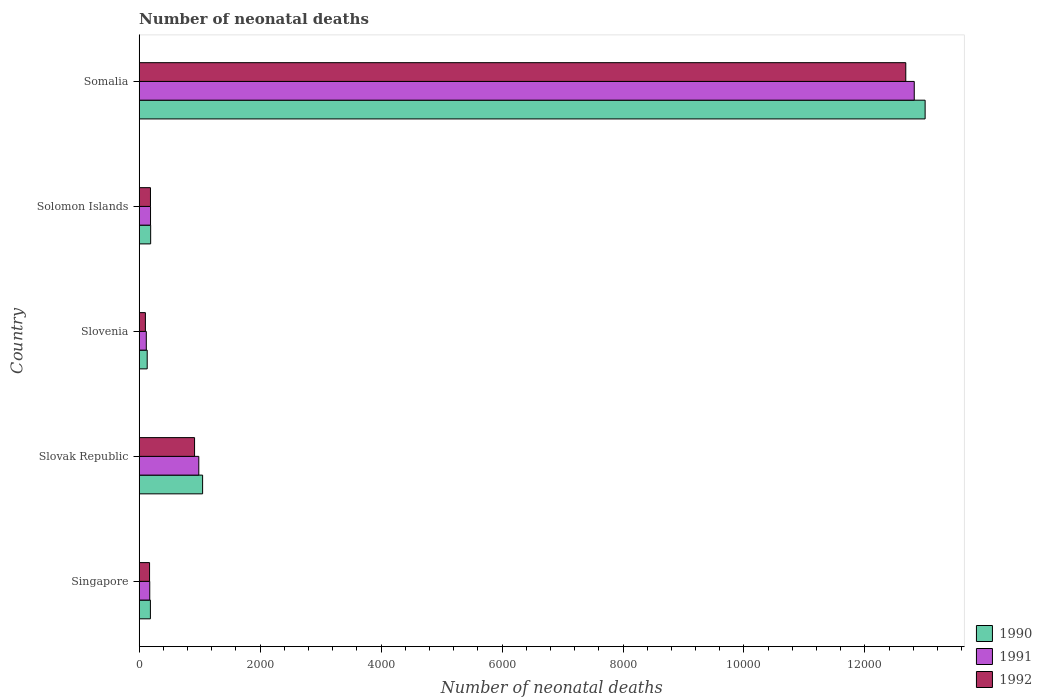How many different coloured bars are there?
Make the answer very short. 3. How many bars are there on the 5th tick from the top?
Your response must be concise. 3. What is the label of the 1st group of bars from the top?
Offer a terse response. Somalia. In how many cases, is the number of bars for a given country not equal to the number of legend labels?
Make the answer very short. 0. What is the number of neonatal deaths in in 1992 in Slovak Republic?
Provide a short and direct response. 916. Across all countries, what is the maximum number of neonatal deaths in in 1991?
Your answer should be compact. 1.28e+04. Across all countries, what is the minimum number of neonatal deaths in in 1991?
Offer a terse response. 118. In which country was the number of neonatal deaths in in 1990 maximum?
Your answer should be compact. Somalia. In which country was the number of neonatal deaths in in 1992 minimum?
Give a very brief answer. Slovenia. What is the total number of neonatal deaths in in 1992 in the graph?
Make the answer very short. 1.41e+04. What is the difference between the number of neonatal deaths in in 1990 in Singapore and that in Solomon Islands?
Give a very brief answer. -4. What is the difference between the number of neonatal deaths in in 1992 in Slovak Republic and the number of neonatal deaths in in 1991 in Solomon Islands?
Ensure brevity in your answer.  728. What is the average number of neonatal deaths in in 1991 per country?
Ensure brevity in your answer.  2856.4. What is the difference between the number of neonatal deaths in in 1990 and number of neonatal deaths in in 1992 in Slovenia?
Provide a succinct answer. 30. In how many countries, is the number of neonatal deaths in in 1992 greater than 10400 ?
Ensure brevity in your answer.  1. What is the ratio of the number of neonatal deaths in in 1992 in Singapore to that in Slovenia?
Ensure brevity in your answer.  1.67. What is the difference between the highest and the second highest number of neonatal deaths in in 1992?
Your answer should be very brief. 1.18e+04. What is the difference between the highest and the lowest number of neonatal deaths in in 1991?
Ensure brevity in your answer.  1.27e+04. In how many countries, is the number of neonatal deaths in in 1992 greater than the average number of neonatal deaths in in 1992 taken over all countries?
Your response must be concise. 1. What does the 3rd bar from the bottom in Slovenia represents?
Your response must be concise. 1992. Is it the case that in every country, the sum of the number of neonatal deaths in in 1991 and number of neonatal deaths in in 1990 is greater than the number of neonatal deaths in in 1992?
Offer a terse response. Yes. How many bars are there?
Your response must be concise. 15. Are all the bars in the graph horizontal?
Offer a very short reply. Yes. How many countries are there in the graph?
Offer a terse response. 5. What is the difference between two consecutive major ticks on the X-axis?
Your response must be concise. 2000. Are the values on the major ticks of X-axis written in scientific E-notation?
Offer a very short reply. No. How are the legend labels stacked?
Ensure brevity in your answer.  Vertical. What is the title of the graph?
Offer a very short reply. Number of neonatal deaths. What is the label or title of the X-axis?
Offer a very short reply. Number of neonatal deaths. What is the Number of neonatal deaths of 1990 in Singapore?
Your answer should be compact. 186. What is the Number of neonatal deaths in 1991 in Singapore?
Your response must be concise. 175. What is the Number of neonatal deaths of 1992 in Singapore?
Offer a very short reply. 172. What is the Number of neonatal deaths of 1990 in Slovak Republic?
Ensure brevity in your answer.  1049. What is the Number of neonatal deaths of 1991 in Slovak Republic?
Give a very brief answer. 986. What is the Number of neonatal deaths in 1992 in Slovak Republic?
Ensure brevity in your answer.  916. What is the Number of neonatal deaths of 1990 in Slovenia?
Ensure brevity in your answer.  133. What is the Number of neonatal deaths of 1991 in Slovenia?
Your answer should be very brief. 118. What is the Number of neonatal deaths in 1992 in Slovenia?
Give a very brief answer. 103. What is the Number of neonatal deaths of 1990 in Solomon Islands?
Your response must be concise. 190. What is the Number of neonatal deaths of 1991 in Solomon Islands?
Provide a succinct answer. 188. What is the Number of neonatal deaths of 1992 in Solomon Islands?
Provide a succinct answer. 187. What is the Number of neonatal deaths of 1990 in Somalia?
Offer a terse response. 1.30e+04. What is the Number of neonatal deaths of 1991 in Somalia?
Offer a very short reply. 1.28e+04. What is the Number of neonatal deaths of 1992 in Somalia?
Give a very brief answer. 1.27e+04. Across all countries, what is the maximum Number of neonatal deaths of 1990?
Offer a terse response. 1.30e+04. Across all countries, what is the maximum Number of neonatal deaths of 1991?
Provide a short and direct response. 1.28e+04. Across all countries, what is the maximum Number of neonatal deaths in 1992?
Ensure brevity in your answer.  1.27e+04. Across all countries, what is the minimum Number of neonatal deaths of 1990?
Make the answer very short. 133. Across all countries, what is the minimum Number of neonatal deaths of 1991?
Provide a short and direct response. 118. Across all countries, what is the minimum Number of neonatal deaths in 1992?
Ensure brevity in your answer.  103. What is the total Number of neonatal deaths of 1990 in the graph?
Your answer should be very brief. 1.46e+04. What is the total Number of neonatal deaths in 1991 in the graph?
Provide a short and direct response. 1.43e+04. What is the total Number of neonatal deaths in 1992 in the graph?
Offer a very short reply. 1.41e+04. What is the difference between the Number of neonatal deaths in 1990 in Singapore and that in Slovak Republic?
Provide a short and direct response. -863. What is the difference between the Number of neonatal deaths of 1991 in Singapore and that in Slovak Republic?
Provide a short and direct response. -811. What is the difference between the Number of neonatal deaths in 1992 in Singapore and that in Slovak Republic?
Your response must be concise. -744. What is the difference between the Number of neonatal deaths in 1991 in Singapore and that in Slovenia?
Provide a succinct answer. 57. What is the difference between the Number of neonatal deaths of 1992 in Singapore and that in Solomon Islands?
Ensure brevity in your answer.  -15. What is the difference between the Number of neonatal deaths in 1990 in Singapore and that in Somalia?
Offer a terse response. -1.28e+04. What is the difference between the Number of neonatal deaths of 1991 in Singapore and that in Somalia?
Give a very brief answer. -1.26e+04. What is the difference between the Number of neonatal deaths of 1992 in Singapore and that in Somalia?
Offer a very short reply. -1.25e+04. What is the difference between the Number of neonatal deaths of 1990 in Slovak Republic and that in Slovenia?
Offer a terse response. 916. What is the difference between the Number of neonatal deaths in 1991 in Slovak Republic and that in Slovenia?
Your answer should be compact. 868. What is the difference between the Number of neonatal deaths in 1992 in Slovak Republic and that in Slovenia?
Ensure brevity in your answer.  813. What is the difference between the Number of neonatal deaths in 1990 in Slovak Republic and that in Solomon Islands?
Provide a succinct answer. 859. What is the difference between the Number of neonatal deaths of 1991 in Slovak Republic and that in Solomon Islands?
Keep it short and to the point. 798. What is the difference between the Number of neonatal deaths in 1992 in Slovak Republic and that in Solomon Islands?
Your response must be concise. 729. What is the difference between the Number of neonatal deaths in 1990 in Slovak Republic and that in Somalia?
Offer a terse response. -1.19e+04. What is the difference between the Number of neonatal deaths of 1991 in Slovak Republic and that in Somalia?
Your response must be concise. -1.18e+04. What is the difference between the Number of neonatal deaths of 1992 in Slovak Republic and that in Somalia?
Give a very brief answer. -1.18e+04. What is the difference between the Number of neonatal deaths in 1990 in Slovenia and that in Solomon Islands?
Your response must be concise. -57. What is the difference between the Number of neonatal deaths in 1991 in Slovenia and that in Solomon Islands?
Give a very brief answer. -70. What is the difference between the Number of neonatal deaths in 1992 in Slovenia and that in Solomon Islands?
Your answer should be compact. -84. What is the difference between the Number of neonatal deaths of 1990 in Slovenia and that in Somalia?
Give a very brief answer. -1.29e+04. What is the difference between the Number of neonatal deaths of 1991 in Slovenia and that in Somalia?
Offer a terse response. -1.27e+04. What is the difference between the Number of neonatal deaths in 1992 in Slovenia and that in Somalia?
Your answer should be very brief. -1.26e+04. What is the difference between the Number of neonatal deaths in 1990 in Solomon Islands and that in Somalia?
Keep it short and to the point. -1.28e+04. What is the difference between the Number of neonatal deaths of 1991 in Solomon Islands and that in Somalia?
Provide a short and direct response. -1.26e+04. What is the difference between the Number of neonatal deaths in 1992 in Solomon Islands and that in Somalia?
Provide a short and direct response. -1.25e+04. What is the difference between the Number of neonatal deaths of 1990 in Singapore and the Number of neonatal deaths of 1991 in Slovak Republic?
Your answer should be very brief. -800. What is the difference between the Number of neonatal deaths of 1990 in Singapore and the Number of neonatal deaths of 1992 in Slovak Republic?
Your answer should be compact. -730. What is the difference between the Number of neonatal deaths of 1991 in Singapore and the Number of neonatal deaths of 1992 in Slovak Republic?
Provide a succinct answer. -741. What is the difference between the Number of neonatal deaths of 1990 in Singapore and the Number of neonatal deaths of 1992 in Slovenia?
Give a very brief answer. 83. What is the difference between the Number of neonatal deaths in 1990 in Singapore and the Number of neonatal deaths in 1991 in Somalia?
Offer a very short reply. -1.26e+04. What is the difference between the Number of neonatal deaths in 1990 in Singapore and the Number of neonatal deaths in 1992 in Somalia?
Provide a succinct answer. -1.25e+04. What is the difference between the Number of neonatal deaths in 1991 in Singapore and the Number of neonatal deaths in 1992 in Somalia?
Your answer should be very brief. -1.25e+04. What is the difference between the Number of neonatal deaths in 1990 in Slovak Republic and the Number of neonatal deaths in 1991 in Slovenia?
Offer a terse response. 931. What is the difference between the Number of neonatal deaths in 1990 in Slovak Republic and the Number of neonatal deaths in 1992 in Slovenia?
Offer a very short reply. 946. What is the difference between the Number of neonatal deaths of 1991 in Slovak Republic and the Number of neonatal deaths of 1992 in Slovenia?
Offer a terse response. 883. What is the difference between the Number of neonatal deaths of 1990 in Slovak Republic and the Number of neonatal deaths of 1991 in Solomon Islands?
Ensure brevity in your answer.  861. What is the difference between the Number of neonatal deaths of 1990 in Slovak Republic and the Number of neonatal deaths of 1992 in Solomon Islands?
Give a very brief answer. 862. What is the difference between the Number of neonatal deaths of 1991 in Slovak Republic and the Number of neonatal deaths of 1992 in Solomon Islands?
Keep it short and to the point. 799. What is the difference between the Number of neonatal deaths in 1990 in Slovak Republic and the Number of neonatal deaths in 1991 in Somalia?
Your response must be concise. -1.18e+04. What is the difference between the Number of neonatal deaths in 1990 in Slovak Republic and the Number of neonatal deaths in 1992 in Somalia?
Provide a short and direct response. -1.16e+04. What is the difference between the Number of neonatal deaths in 1991 in Slovak Republic and the Number of neonatal deaths in 1992 in Somalia?
Keep it short and to the point. -1.17e+04. What is the difference between the Number of neonatal deaths in 1990 in Slovenia and the Number of neonatal deaths in 1991 in Solomon Islands?
Your answer should be very brief. -55. What is the difference between the Number of neonatal deaths in 1990 in Slovenia and the Number of neonatal deaths in 1992 in Solomon Islands?
Your answer should be very brief. -54. What is the difference between the Number of neonatal deaths of 1991 in Slovenia and the Number of neonatal deaths of 1992 in Solomon Islands?
Your answer should be compact. -69. What is the difference between the Number of neonatal deaths of 1990 in Slovenia and the Number of neonatal deaths of 1991 in Somalia?
Your answer should be very brief. -1.27e+04. What is the difference between the Number of neonatal deaths of 1990 in Slovenia and the Number of neonatal deaths of 1992 in Somalia?
Your answer should be compact. -1.25e+04. What is the difference between the Number of neonatal deaths of 1991 in Slovenia and the Number of neonatal deaths of 1992 in Somalia?
Provide a short and direct response. -1.26e+04. What is the difference between the Number of neonatal deaths in 1990 in Solomon Islands and the Number of neonatal deaths in 1991 in Somalia?
Keep it short and to the point. -1.26e+04. What is the difference between the Number of neonatal deaths in 1990 in Solomon Islands and the Number of neonatal deaths in 1992 in Somalia?
Provide a short and direct response. -1.25e+04. What is the difference between the Number of neonatal deaths of 1991 in Solomon Islands and the Number of neonatal deaths of 1992 in Somalia?
Ensure brevity in your answer.  -1.25e+04. What is the average Number of neonatal deaths of 1990 per country?
Make the answer very short. 2910.6. What is the average Number of neonatal deaths of 1991 per country?
Offer a terse response. 2856.4. What is the average Number of neonatal deaths of 1992 per country?
Your answer should be compact. 2810.6. What is the difference between the Number of neonatal deaths of 1990 and Number of neonatal deaths of 1992 in Slovak Republic?
Offer a terse response. 133. What is the difference between the Number of neonatal deaths of 1991 and Number of neonatal deaths of 1992 in Slovak Republic?
Offer a terse response. 70. What is the difference between the Number of neonatal deaths in 1991 and Number of neonatal deaths in 1992 in Slovenia?
Ensure brevity in your answer.  15. What is the difference between the Number of neonatal deaths of 1990 and Number of neonatal deaths of 1991 in Solomon Islands?
Offer a terse response. 2. What is the difference between the Number of neonatal deaths in 1990 and Number of neonatal deaths in 1992 in Solomon Islands?
Your answer should be very brief. 3. What is the difference between the Number of neonatal deaths in 1991 and Number of neonatal deaths in 1992 in Solomon Islands?
Make the answer very short. 1. What is the difference between the Number of neonatal deaths in 1990 and Number of neonatal deaths in 1991 in Somalia?
Your response must be concise. 180. What is the difference between the Number of neonatal deaths in 1990 and Number of neonatal deaths in 1992 in Somalia?
Offer a very short reply. 320. What is the difference between the Number of neonatal deaths of 1991 and Number of neonatal deaths of 1992 in Somalia?
Your answer should be compact. 140. What is the ratio of the Number of neonatal deaths in 1990 in Singapore to that in Slovak Republic?
Offer a terse response. 0.18. What is the ratio of the Number of neonatal deaths of 1991 in Singapore to that in Slovak Republic?
Your response must be concise. 0.18. What is the ratio of the Number of neonatal deaths of 1992 in Singapore to that in Slovak Republic?
Offer a very short reply. 0.19. What is the ratio of the Number of neonatal deaths of 1990 in Singapore to that in Slovenia?
Make the answer very short. 1.4. What is the ratio of the Number of neonatal deaths of 1991 in Singapore to that in Slovenia?
Offer a very short reply. 1.48. What is the ratio of the Number of neonatal deaths of 1992 in Singapore to that in Slovenia?
Keep it short and to the point. 1.67. What is the ratio of the Number of neonatal deaths of 1990 in Singapore to that in Solomon Islands?
Keep it short and to the point. 0.98. What is the ratio of the Number of neonatal deaths in 1991 in Singapore to that in Solomon Islands?
Keep it short and to the point. 0.93. What is the ratio of the Number of neonatal deaths of 1992 in Singapore to that in Solomon Islands?
Ensure brevity in your answer.  0.92. What is the ratio of the Number of neonatal deaths in 1990 in Singapore to that in Somalia?
Your answer should be compact. 0.01. What is the ratio of the Number of neonatal deaths of 1991 in Singapore to that in Somalia?
Keep it short and to the point. 0.01. What is the ratio of the Number of neonatal deaths in 1992 in Singapore to that in Somalia?
Your response must be concise. 0.01. What is the ratio of the Number of neonatal deaths in 1990 in Slovak Republic to that in Slovenia?
Provide a short and direct response. 7.89. What is the ratio of the Number of neonatal deaths in 1991 in Slovak Republic to that in Slovenia?
Keep it short and to the point. 8.36. What is the ratio of the Number of neonatal deaths in 1992 in Slovak Republic to that in Slovenia?
Ensure brevity in your answer.  8.89. What is the ratio of the Number of neonatal deaths in 1990 in Slovak Republic to that in Solomon Islands?
Your answer should be compact. 5.52. What is the ratio of the Number of neonatal deaths in 1991 in Slovak Republic to that in Solomon Islands?
Provide a short and direct response. 5.24. What is the ratio of the Number of neonatal deaths in 1992 in Slovak Republic to that in Solomon Islands?
Your answer should be compact. 4.9. What is the ratio of the Number of neonatal deaths of 1990 in Slovak Republic to that in Somalia?
Your answer should be very brief. 0.08. What is the ratio of the Number of neonatal deaths of 1991 in Slovak Republic to that in Somalia?
Offer a terse response. 0.08. What is the ratio of the Number of neonatal deaths of 1992 in Slovak Republic to that in Somalia?
Your answer should be very brief. 0.07. What is the ratio of the Number of neonatal deaths in 1991 in Slovenia to that in Solomon Islands?
Offer a very short reply. 0.63. What is the ratio of the Number of neonatal deaths in 1992 in Slovenia to that in Solomon Islands?
Offer a very short reply. 0.55. What is the ratio of the Number of neonatal deaths of 1990 in Slovenia to that in Somalia?
Keep it short and to the point. 0.01. What is the ratio of the Number of neonatal deaths in 1991 in Slovenia to that in Somalia?
Provide a short and direct response. 0.01. What is the ratio of the Number of neonatal deaths of 1992 in Slovenia to that in Somalia?
Give a very brief answer. 0.01. What is the ratio of the Number of neonatal deaths of 1990 in Solomon Islands to that in Somalia?
Your answer should be compact. 0.01. What is the ratio of the Number of neonatal deaths in 1991 in Solomon Islands to that in Somalia?
Your answer should be very brief. 0.01. What is the ratio of the Number of neonatal deaths of 1992 in Solomon Islands to that in Somalia?
Ensure brevity in your answer.  0.01. What is the difference between the highest and the second highest Number of neonatal deaths in 1990?
Give a very brief answer. 1.19e+04. What is the difference between the highest and the second highest Number of neonatal deaths in 1991?
Your answer should be very brief. 1.18e+04. What is the difference between the highest and the second highest Number of neonatal deaths in 1992?
Ensure brevity in your answer.  1.18e+04. What is the difference between the highest and the lowest Number of neonatal deaths of 1990?
Keep it short and to the point. 1.29e+04. What is the difference between the highest and the lowest Number of neonatal deaths in 1991?
Provide a short and direct response. 1.27e+04. What is the difference between the highest and the lowest Number of neonatal deaths in 1992?
Your response must be concise. 1.26e+04. 